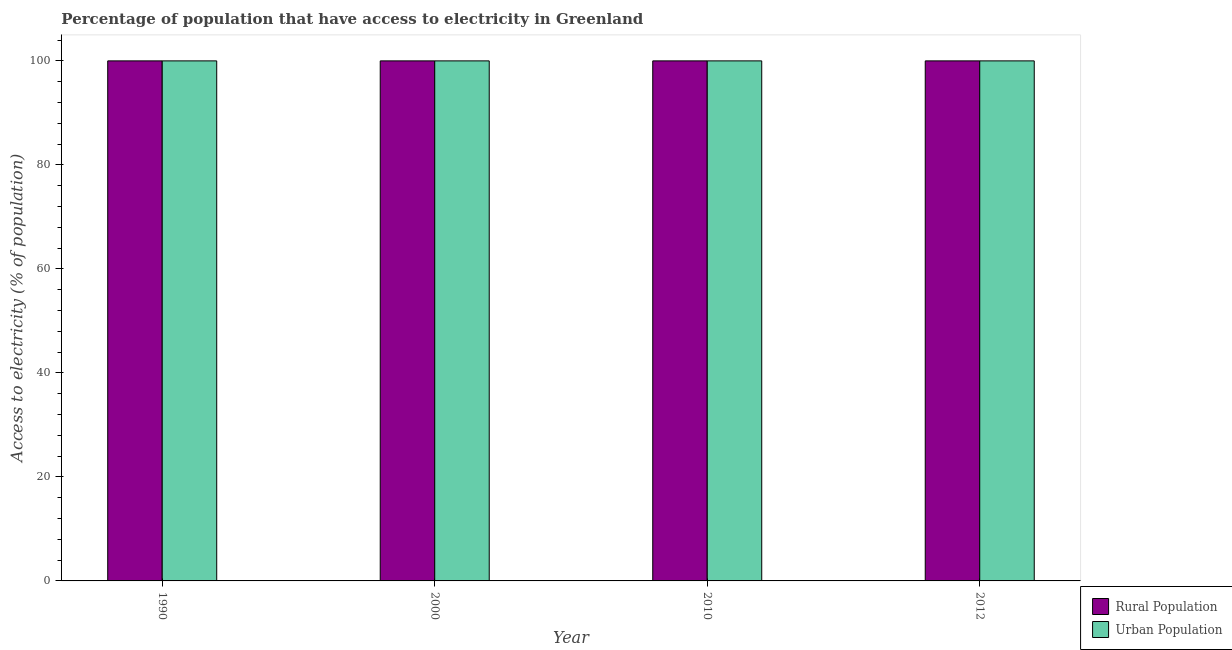How many groups of bars are there?
Ensure brevity in your answer.  4. Are the number of bars on each tick of the X-axis equal?
Provide a short and direct response. Yes. What is the label of the 3rd group of bars from the left?
Offer a terse response. 2010. In how many cases, is the number of bars for a given year not equal to the number of legend labels?
Your answer should be very brief. 0. What is the percentage of rural population having access to electricity in 2010?
Give a very brief answer. 100. Across all years, what is the maximum percentage of urban population having access to electricity?
Provide a short and direct response. 100. Across all years, what is the minimum percentage of rural population having access to electricity?
Your answer should be very brief. 100. In which year was the percentage of rural population having access to electricity maximum?
Offer a very short reply. 1990. What is the total percentage of urban population having access to electricity in the graph?
Provide a short and direct response. 400. What is the difference between the percentage of urban population having access to electricity in 1990 and the percentage of rural population having access to electricity in 2010?
Provide a succinct answer. 0. What is the average percentage of rural population having access to electricity per year?
Make the answer very short. 100. What is the ratio of the percentage of rural population having access to electricity in 2000 to that in 2010?
Provide a short and direct response. 1. Is the percentage of rural population having access to electricity in 2010 less than that in 2012?
Your answer should be compact. No. Is the difference between the percentage of urban population having access to electricity in 2010 and 2012 greater than the difference between the percentage of rural population having access to electricity in 2010 and 2012?
Provide a short and direct response. No. What is the difference between the highest and the second highest percentage of urban population having access to electricity?
Provide a succinct answer. 0. In how many years, is the percentage of urban population having access to electricity greater than the average percentage of urban population having access to electricity taken over all years?
Offer a terse response. 0. What does the 2nd bar from the left in 2012 represents?
Provide a succinct answer. Urban Population. What does the 1st bar from the right in 2012 represents?
Your answer should be very brief. Urban Population. Are all the bars in the graph horizontal?
Your response must be concise. No. What is the difference between two consecutive major ticks on the Y-axis?
Provide a succinct answer. 20. Are the values on the major ticks of Y-axis written in scientific E-notation?
Offer a terse response. No. Does the graph contain grids?
Your response must be concise. No. Where does the legend appear in the graph?
Give a very brief answer. Bottom right. What is the title of the graph?
Offer a very short reply. Percentage of population that have access to electricity in Greenland. Does "current US$" appear as one of the legend labels in the graph?
Make the answer very short. No. What is the label or title of the Y-axis?
Give a very brief answer. Access to electricity (% of population). What is the Access to electricity (% of population) of Rural Population in 1990?
Keep it short and to the point. 100. What is the Access to electricity (% of population) in Rural Population in 2010?
Offer a very short reply. 100. What is the Access to electricity (% of population) in Urban Population in 2010?
Give a very brief answer. 100. What is the Access to electricity (% of population) in Rural Population in 2012?
Provide a succinct answer. 100. What is the Access to electricity (% of population) in Urban Population in 2012?
Offer a terse response. 100. Across all years, what is the maximum Access to electricity (% of population) of Urban Population?
Provide a short and direct response. 100. Across all years, what is the minimum Access to electricity (% of population) of Rural Population?
Your response must be concise. 100. Across all years, what is the minimum Access to electricity (% of population) in Urban Population?
Provide a short and direct response. 100. What is the difference between the Access to electricity (% of population) of Rural Population in 1990 and that in 2000?
Your answer should be compact. 0. What is the difference between the Access to electricity (% of population) of Rural Population in 2000 and that in 2010?
Ensure brevity in your answer.  0. What is the difference between the Access to electricity (% of population) in Rural Population in 2000 and that in 2012?
Your answer should be very brief. 0. What is the difference between the Access to electricity (% of population) of Rural Population in 2010 and that in 2012?
Your answer should be compact. 0. What is the difference between the Access to electricity (% of population) of Urban Population in 2010 and that in 2012?
Your response must be concise. 0. What is the difference between the Access to electricity (% of population) of Rural Population in 1990 and the Access to electricity (% of population) of Urban Population in 2000?
Provide a succinct answer. 0. What is the difference between the Access to electricity (% of population) in Rural Population in 1990 and the Access to electricity (% of population) in Urban Population in 2010?
Your answer should be very brief. 0. What is the difference between the Access to electricity (% of population) in Rural Population in 2000 and the Access to electricity (% of population) in Urban Population in 2012?
Keep it short and to the point. 0. What is the difference between the Access to electricity (% of population) in Rural Population in 2010 and the Access to electricity (% of population) in Urban Population in 2012?
Ensure brevity in your answer.  0. In the year 2010, what is the difference between the Access to electricity (% of population) of Rural Population and Access to electricity (% of population) of Urban Population?
Make the answer very short. 0. In the year 2012, what is the difference between the Access to electricity (% of population) of Rural Population and Access to electricity (% of population) of Urban Population?
Your answer should be very brief. 0. What is the ratio of the Access to electricity (% of population) of Rural Population in 1990 to that in 2000?
Provide a short and direct response. 1. What is the ratio of the Access to electricity (% of population) of Rural Population in 1990 to that in 2012?
Ensure brevity in your answer.  1. What is the ratio of the Access to electricity (% of population) in Urban Population in 1990 to that in 2012?
Your response must be concise. 1. What is the ratio of the Access to electricity (% of population) in Rural Population in 2000 to that in 2010?
Ensure brevity in your answer.  1. What is the ratio of the Access to electricity (% of population) of Urban Population in 2000 to that in 2010?
Your response must be concise. 1. What is the ratio of the Access to electricity (% of population) of Urban Population in 2000 to that in 2012?
Offer a very short reply. 1. What is the ratio of the Access to electricity (% of population) in Rural Population in 2010 to that in 2012?
Give a very brief answer. 1. What is the ratio of the Access to electricity (% of population) in Urban Population in 2010 to that in 2012?
Give a very brief answer. 1. What is the difference between the highest and the lowest Access to electricity (% of population) of Rural Population?
Offer a terse response. 0. 